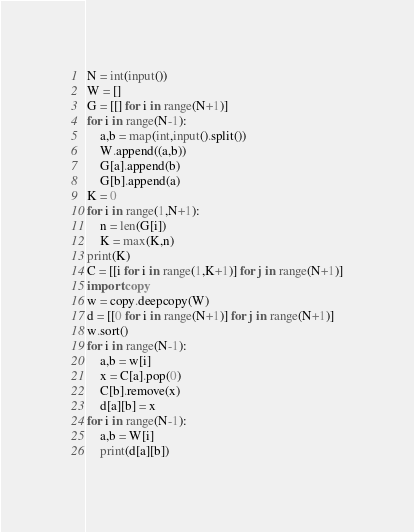<code> <loc_0><loc_0><loc_500><loc_500><_Python_>N = int(input())
W = []
G = [[] for i in range(N+1)]
for i in range(N-1):
    a,b = map(int,input().split())
    W.append((a,b))
    G[a].append(b)
    G[b].append(a)
K = 0
for i in range(1,N+1):
    n = len(G[i])
    K = max(K,n)
print(K)
C = [[i for i in range(1,K+1)] for j in range(N+1)]
import copy 
w = copy.deepcopy(W)
d = [[0 for i in range(N+1)] for j in range(N+1)]
w.sort()
for i in range(N-1):
    a,b = w[i]
    x = C[a].pop(0)
    C[b].remove(x)
    d[a][b] = x
for i in range(N-1):
    a,b = W[i]
    print(d[a][b])
</code> 